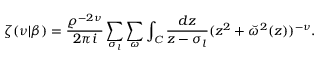Convert formula to latex. <formula><loc_0><loc_0><loc_500><loc_500>\zeta ( \nu | \beta ) = { \frac { \varrho ^ { - 2 \nu } } { 2 \pi i } } \sum _ { \sigma _ { l } } \sum _ { \omega } \int _ { C } { \frac { d z } { z - \sigma _ { l } } } ( z ^ { 2 } + \breve { \omega } ^ { 2 } ( z ) ) ^ { - \nu } .</formula> 